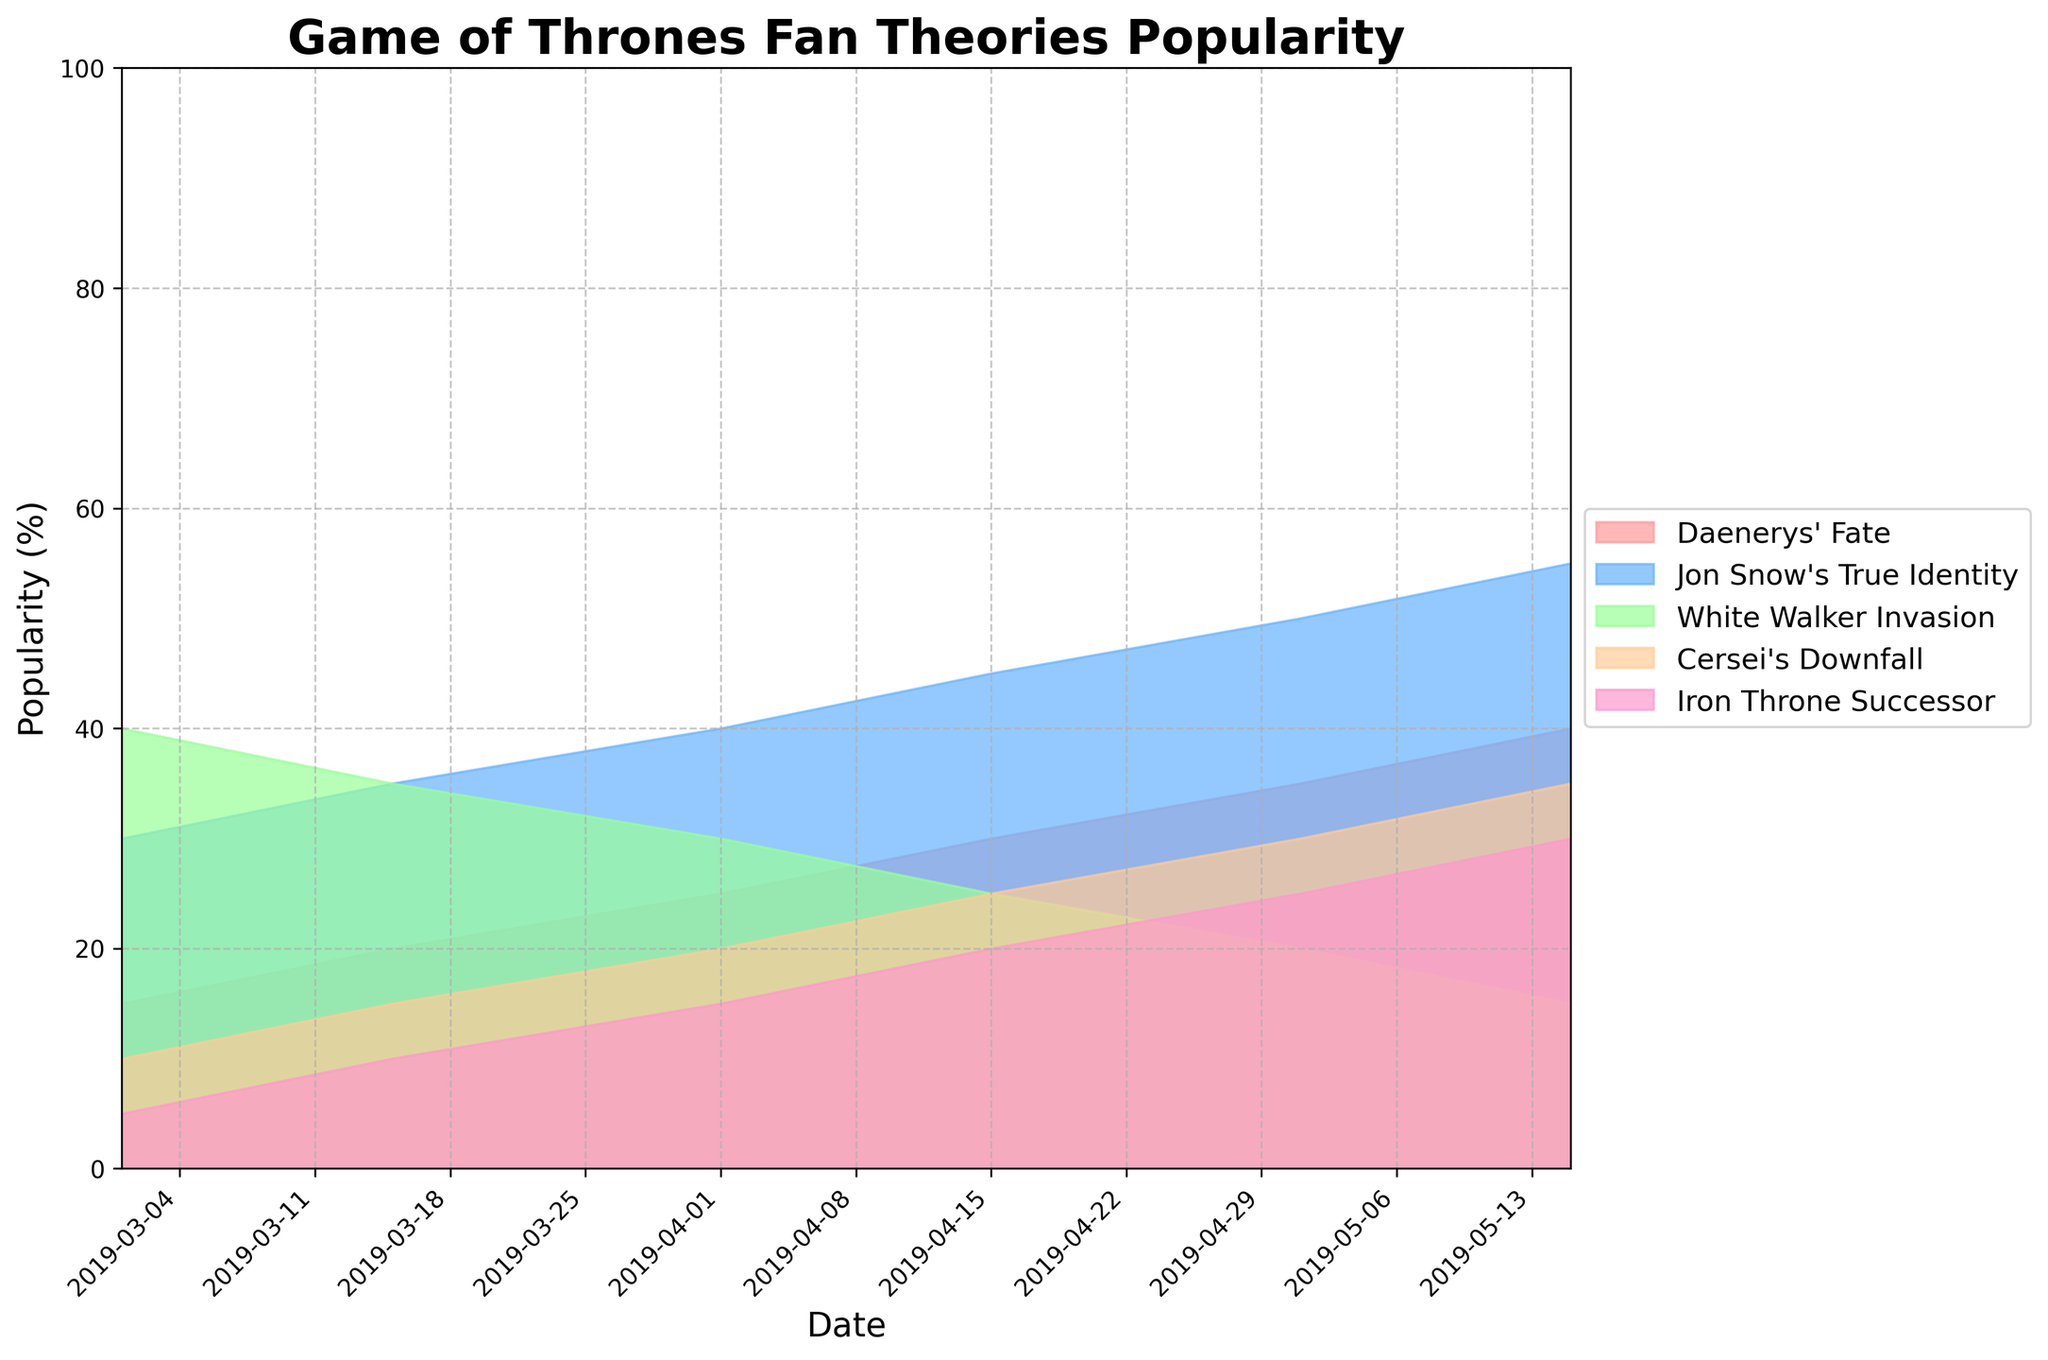What's the title of the plot? The title is the most prominent text, typically located at the top of the graph.
Answer: Game of Thrones Fan Theories Popularity On which date did the popularity of 'Daenerys' Fate' first reach 30%? Locate the 'Daenerys' Fate' line and find the point where it first hits 30%.
Answer: 2019-04-15 How many main plot points are tracked in the graph? Count the number of distinct lines or areas in the plot, each representing a different plot point.
Answer: 5 Which plot point experienced the most significant increase in popularity from March 1 to May 15, 2019? Calculate the difference in popularity for each plot point between the two dates and identify the largest increase.
Answer: Daenerys' Fate By how many percentage points did the popularity of 'White Walker Invasion' decline from March 1 to May 15, 2019? Subtract the percentage on March 1 from the percentage on May 15 for 'White Walker Invasion'.
Answer: -25 Compare the popularity of 'Iron Throne Successor' and 'Cersei's Downfall' on April 15, 2019. Which one was more popular? Locate the values for both plot points on April 15 and compare them.
Answer: Cersei's Downfall What is the overall trend for the popularity of 'Jon Snow's True Identity' over the given dates? Observe the line or area for 'Jon Snow’s True Identity' and describe its general direction.
Answer: Increasing Which plot point had the least popularity on March 1, 2019, and what was its popularity percentage? Identify the lowest percentage value on March 1 and the corresponding plot point.
Answer: Iron Throne Successor (5%) On May 1, 2019, what is the combined popularity percentage of 'Cersei's Downfall' and 'Iron Throne Successor'? Add the percentages for both plot points on May 1, 2019.
Answer: 55 Which plot point shows a steady increase in popularity without any declines? Look at the lines for each plot point and identify any that only move upward over time.
Answer: Daenerys' Fate 